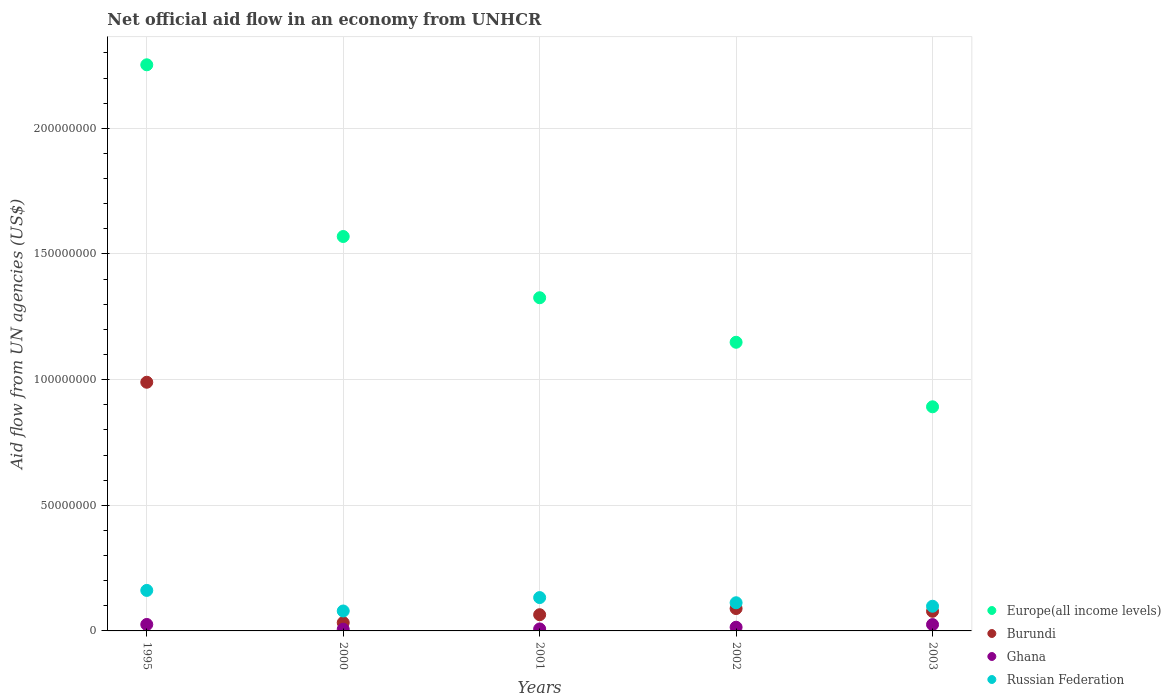How many different coloured dotlines are there?
Offer a terse response. 4. Is the number of dotlines equal to the number of legend labels?
Provide a short and direct response. Yes. What is the net official aid flow in Russian Federation in 2003?
Offer a very short reply. 9.82e+06. Across all years, what is the maximum net official aid flow in Europe(all income levels)?
Ensure brevity in your answer.  2.25e+08. Across all years, what is the minimum net official aid flow in Europe(all income levels)?
Your answer should be compact. 8.92e+07. In which year was the net official aid flow in Ghana maximum?
Keep it short and to the point. 1995. In which year was the net official aid flow in Europe(all income levels) minimum?
Offer a terse response. 2003. What is the total net official aid flow in Burundi in the graph?
Offer a very short reply. 1.25e+08. What is the difference between the net official aid flow in Burundi in 2001 and that in 2003?
Offer a very short reply. -1.36e+06. What is the difference between the net official aid flow in Europe(all income levels) in 2002 and the net official aid flow in Ghana in 2001?
Ensure brevity in your answer.  1.14e+08. What is the average net official aid flow in Europe(all income levels) per year?
Provide a short and direct response. 1.44e+08. In the year 2000, what is the difference between the net official aid flow in Russian Federation and net official aid flow in Ghana?
Your answer should be compact. 7.25e+06. What is the ratio of the net official aid flow in Ghana in 1995 to that in 2001?
Offer a very short reply. 3.25. What is the difference between the highest and the second highest net official aid flow in Ghana?
Provide a succinct answer. 4.00e+04. What is the difference between the highest and the lowest net official aid flow in Europe(all income levels)?
Offer a terse response. 1.36e+08. Is the sum of the net official aid flow in Europe(all income levels) in 2001 and 2003 greater than the maximum net official aid flow in Russian Federation across all years?
Give a very brief answer. Yes. Is it the case that in every year, the sum of the net official aid flow in Burundi and net official aid flow in Ghana  is greater than the net official aid flow in Europe(all income levels)?
Keep it short and to the point. No. Is the net official aid flow in Ghana strictly greater than the net official aid flow in Europe(all income levels) over the years?
Provide a succinct answer. No. How many years are there in the graph?
Your response must be concise. 5. Are the values on the major ticks of Y-axis written in scientific E-notation?
Give a very brief answer. No. Where does the legend appear in the graph?
Make the answer very short. Bottom right. How are the legend labels stacked?
Provide a short and direct response. Vertical. What is the title of the graph?
Give a very brief answer. Net official aid flow in an economy from UNHCR. What is the label or title of the X-axis?
Offer a terse response. Years. What is the label or title of the Y-axis?
Offer a very short reply. Aid flow from UN agencies (US$). What is the Aid flow from UN agencies (US$) in Europe(all income levels) in 1995?
Offer a terse response. 2.25e+08. What is the Aid flow from UN agencies (US$) of Burundi in 1995?
Give a very brief answer. 9.90e+07. What is the Aid flow from UN agencies (US$) in Ghana in 1995?
Give a very brief answer. 2.57e+06. What is the Aid flow from UN agencies (US$) in Russian Federation in 1995?
Offer a terse response. 1.61e+07. What is the Aid flow from UN agencies (US$) of Europe(all income levels) in 2000?
Your response must be concise. 1.57e+08. What is the Aid flow from UN agencies (US$) of Burundi in 2000?
Give a very brief answer. 3.29e+06. What is the Aid flow from UN agencies (US$) of Ghana in 2000?
Provide a short and direct response. 6.80e+05. What is the Aid flow from UN agencies (US$) of Russian Federation in 2000?
Offer a very short reply. 7.93e+06. What is the Aid flow from UN agencies (US$) of Europe(all income levels) in 2001?
Your response must be concise. 1.33e+08. What is the Aid flow from UN agencies (US$) of Burundi in 2001?
Offer a very short reply. 6.45e+06. What is the Aid flow from UN agencies (US$) in Ghana in 2001?
Your answer should be compact. 7.90e+05. What is the Aid flow from UN agencies (US$) of Russian Federation in 2001?
Your answer should be very brief. 1.33e+07. What is the Aid flow from UN agencies (US$) of Europe(all income levels) in 2002?
Your answer should be very brief. 1.15e+08. What is the Aid flow from UN agencies (US$) in Burundi in 2002?
Give a very brief answer. 8.90e+06. What is the Aid flow from UN agencies (US$) of Ghana in 2002?
Offer a very short reply. 1.47e+06. What is the Aid flow from UN agencies (US$) of Russian Federation in 2002?
Give a very brief answer. 1.12e+07. What is the Aid flow from UN agencies (US$) of Europe(all income levels) in 2003?
Give a very brief answer. 8.92e+07. What is the Aid flow from UN agencies (US$) in Burundi in 2003?
Keep it short and to the point. 7.81e+06. What is the Aid flow from UN agencies (US$) in Ghana in 2003?
Make the answer very short. 2.53e+06. What is the Aid flow from UN agencies (US$) in Russian Federation in 2003?
Keep it short and to the point. 9.82e+06. Across all years, what is the maximum Aid flow from UN agencies (US$) of Europe(all income levels)?
Offer a very short reply. 2.25e+08. Across all years, what is the maximum Aid flow from UN agencies (US$) of Burundi?
Your response must be concise. 9.90e+07. Across all years, what is the maximum Aid flow from UN agencies (US$) in Ghana?
Make the answer very short. 2.57e+06. Across all years, what is the maximum Aid flow from UN agencies (US$) in Russian Federation?
Offer a very short reply. 1.61e+07. Across all years, what is the minimum Aid flow from UN agencies (US$) of Europe(all income levels)?
Offer a very short reply. 8.92e+07. Across all years, what is the minimum Aid flow from UN agencies (US$) of Burundi?
Keep it short and to the point. 3.29e+06. Across all years, what is the minimum Aid flow from UN agencies (US$) in Ghana?
Provide a short and direct response. 6.80e+05. Across all years, what is the minimum Aid flow from UN agencies (US$) in Russian Federation?
Provide a succinct answer. 7.93e+06. What is the total Aid flow from UN agencies (US$) in Europe(all income levels) in the graph?
Your answer should be compact. 7.19e+08. What is the total Aid flow from UN agencies (US$) of Burundi in the graph?
Provide a short and direct response. 1.25e+08. What is the total Aid flow from UN agencies (US$) of Ghana in the graph?
Keep it short and to the point. 8.04e+06. What is the total Aid flow from UN agencies (US$) in Russian Federation in the graph?
Ensure brevity in your answer.  5.84e+07. What is the difference between the Aid flow from UN agencies (US$) in Europe(all income levels) in 1995 and that in 2000?
Your answer should be compact. 6.83e+07. What is the difference between the Aid flow from UN agencies (US$) of Burundi in 1995 and that in 2000?
Provide a succinct answer. 9.57e+07. What is the difference between the Aid flow from UN agencies (US$) of Ghana in 1995 and that in 2000?
Your answer should be compact. 1.89e+06. What is the difference between the Aid flow from UN agencies (US$) in Russian Federation in 1995 and that in 2000?
Give a very brief answer. 8.19e+06. What is the difference between the Aid flow from UN agencies (US$) of Europe(all income levels) in 1995 and that in 2001?
Make the answer very short. 9.27e+07. What is the difference between the Aid flow from UN agencies (US$) of Burundi in 1995 and that in 2001?
Make the answer very short. 9.25e+07. What is the difference between the Aid flow from UN agencies (US$) in Ghana in 1995 and that in 2001?
Your response must be concise. 1.78e+06. What is the difference between the Aid flow from UN agencies (US$) of Russian Federation in 1995 and that in 2001?
Your answer should be very brief. 2.85e+06. What is the difference between the Aid flow from UN agencies (US$) of Europe(all income levels) in 1995 and that in 2002?
Your answer should be compact. 1.10e+08. What is the difference between the Aid flow from UN agencies (US$) in Burundi in 1995 and that in 2002?
Your response must be concise. 9.01e+07. What is the difference between the Aid flow from UN agencies (US$) in Ghana in 1995 and that in 2002?
Keep it short and to the point. 1.10e+06. What is the difference between the Aid flow from UN agencies (US$) in Russian Federation in 1995 and that in 2002?
Offer a terse response. 4.91e+06. What is the difference between the Aid flow from UN agencies (US$) of Europe(all income levels) in 1995 and that in 2003?
Offer a very short reply. 1.36e+08. What is the difference between the Aid flow from UN agencies (US$) in Burundi in 1995 and that in 2003?
Your answer should be very brief. 9.12e+07. What is the difference between the Aid flow from UN agencies (US$) of Ghana in 1995 and that in 2003?
Your answer should be very brief. 4.00e+04. What is the difference between the Aid flow from UN agencies (US$) in Russian Federation in 1995 and that in 2003?
Ensure brevity in your answer.  6.30e+06. What is the difference between the Aid flow from UN agencies (US$) in Europe(all income levels) in 2000 and that in 2001?
Your response must be concise. 2.44e+07. What is the difference between the Aid flow from UN agencies (US$) of Burundi in 2000 and that in 2001?
Keep it short and to the point. -3.16e+06. What is the difference between the Aid flow from UN agencies (US$) in Ghana in 2000 and that in 2001?
Offer a very short reply. -1.10e+05. What is the difference between the Aid flow from UN agencies (US$) of Russian Federation in 2000 and that in 2001?
Ensure brevity in your answer.  -5.34e+06. What is the difference between the Aid flow from UN agencies (US$) in Europe(all income levels) in 2000 and that in 2002?
Offer a very short reply. 4.21e+07. What is the difference between the Aid flow from UN agencies (US$) of Burundi in 2000 and that in 2002?
Provide a short and direct response. -5.61e+06. What is the difference between the Aid flow from UN agencies (US$) in Ghana in 2000 and that in 2002?
Ensure brevity in your answer.  -7.90e+05. What is the difference between the Aid flow from UN agencies (US$) in Russian Federation in 2000 and that in 2002?
Ensure brevity in your answer.  -3.28e+06. What is the difference between the Aid flow from UN agencies (US$) of Europe(all income levels) in 2000 and that in 2003?
Your answer should be compact. 6.78e+07. What is the difference between the Aid flow from UN agencies (US$) of Burundi in 2000 and that in 2003?
Your answer should be compact. -4.52e+06. What is the difference between the Aid flow from UN agencies (US$) of Ghana in 2000 and that in 2003?
Provide a succinct answer. -1.85e+06. What is the difference between the Aid flow from UN agencies (US$) in Russian Federation in 2000 and that in 2003?
Offer a terse response. -1.89e+06. What is the difference between the Aid flow from UN agencies (US$) of Europe(all income levels) in 2001 and that in 2002?
Your answer should be very brief. 1.77e+07. What is the difference between the Aid flow from UN agencies (US$) of Burundi in 2001 and that in 2002?
Ensure brevity in your answer.  -2.45e+06. What is the difference between the Aid flow from UN agencies (US$) in Ghana in 2001 and that in 2002?
Ensure brevity in your answer.  -6.80e+05. What is the difference between the Aid flow from UN agencies (US$) of Russian Federation in 2001 and that in 2002?
Your answer should be very brief. 2.06e+06. What is the difference between the Aid flow from UN agencies (US$) of Europe(all income levels) in 2001 and that in 2003?
Ensure brevity in your answer.  4.34e+07. What is the difference between the Aid flow from UN agencies (US$) in Burundi in 2001 and that in 2003?
Provide a succinct answer. -1.36e+06. What is the difference between the Aid flow from UN agencies (US$) of Ghana in 2001 and that in 2003?
Your answer should be compact. -1.74e+06. What is the difference between the Aid flow from UN agencies (US$) of Russian Federation in 2001 and that in 2003?
Your response must be concise. 3.45e+06. What is the difference between the Aid flow from UN agencies (US$) of Europe(all income levels) in 2002 and that in 2003?
Provide a succinct answer. 2.57e+07. What is the difference between the Aid flow from UN agencies (US$) in Burundi in 2002 and that in 2003?
Your answer should be very brief. 1.09e+06. What is the difference between the Aid flow from UN agencies (US$) in Ghana in 2002 and that in 2003?
Your answer should be compact. -1.06e+06. What is the difference between the Aid flow from UN agencies (US$) of Russian Federation in 2002 and that in 2003?
Give a very brief answer. 1.39e+06. What is the difference between the Aid flow from UN agencies (US$) in Europe(all income levels) in 1995 and the Aid flow from UN agencies (US$) in Burundi in 2000?
Offer a terse response. 2.22e+08. What is the difference between the Aid flow from UN agencies (US$) in Europe(all income levels) in 1995 and the Aid flow from UN agencies (US$) in Ghana in 2000?
Keep it short and to the point. 2.25e+08. What is the difference between the Aid flow from UN agencies (US$) of Europe(all income levels) in 1995 and the Aid flow from UN agencies (US$) of Russian Federation in 2000?
Provide a succinct answer. 2.17e+08. What is the difference between the Aid flow from UN agencies (US$) in Burundi in 1995 and the Aid flow from UN agencies (US$) in Ghana in 2000?
Keep it short and to the point. 9.83e+07. What is the difference between the Aid flow from UN agencies (US$) of Burundi in 1995 and the Aid flow from UN agencies (US$) of Russian Federation in 2000?
Your response must be concise. 9.10e+07. What is the difference between the Aid flow from UN agencies (US$) in Ghana in 1995 and the Aid flow from UN agencies (US$) in Russian Federation in 2000?
Provide a succinct answer. -5.36e+06. What is the difference between the Aid flow from UN agencies (US$) in Europe(all income levels) in 1995 and the Aid flow from UN agencies (US$) in Burundi in 2001?
Provide a succinct answer. 2.19e+08. What is the difference between the Aid flow from UN agencies (US$) in Europe(all income levels) in 1995 and the Aid flow from UN agencies (US$) in Ghana in 2001?
Ensure brevity in your answer.  2.24e+08. What is the difference between the Aid flow from UN agencies (US$) of Europe(all income levels) in 1995 and the Aid flow from UN agencies (US$) of Russian Federation in 2001?
Offer a very short reply. 2.12e+08. What is the difference between the Aid flow from UN agencies (US$) of Burundi in 1995 and the Aid flow from UN agencies (US$) of Ghana in 2001?
Make the answer very short. 9.82e+07. What is the difference between the Aid flow from UN agencies (US$) of Burundi in 1995 and the Aid flow from UN agencies (US$) of Russian Federation in 2001?
Your answer should be very brief. 8.57e+07. What is the difference between the Aid flow from UN agencies (US$) in Ghana in 1995 and the Aid flow from UN agencies (US$) in Russian Federation in 2001?
Provide a short and direct response. -1.07e+07. What is the difference between the Aid flow from UN agencies (US$) of Europe(all income levels) in 1995 and the Aid flow from UN agencies (US$) of Burundi in 2002?
Provide a succinct answer. 2.16e+08. What is the difference between the Aid flow from UN agencies (US$) in Europe(all income levels) in 1995 and the Aid flow from UN agencies (US$) in Ghana in 2002?
Provide a succinct answer. 2.24e+08. What is the difference between the Aid flow from UN agencies (US$) of Europe(all income levels) in 1995 and the Aid flow from UN agencies (US$) of Russian Federation in 2002?
Offer a very short reply. 2.14e+08. What is the difference between the Aid flow from UN agencies (US$) in Burundi in 1995 and the Aid flow from UN agencies (US$) in Ghana in 2002?
Provide a succinct answer. 9.75e+07. What is the difference between the Aid flow from UN agencies (US$) of Burundi in 1995 and the Aid flow from UN agencies (US$) of Russian Federation in 2002?
Provide a succinct answer. 8.78e+07. What is the difference between the Aid flow from UN agencies (US$) of Ghana in 1995 and the Aid flow from UN agencies (US$) of Russian Federation in 2002?
Your response must be concise. -8.64e+06. What is the difference between the Aid flow from UN agencies (US$) in Europe(all income levels) in 1995 and the Aid flow from UN agencies (US$) in Burundi in 2003?
Offer a terse response. 2.17e+08. What is the difference between the Aid flow from UN agencies (US$) in Europe(all income levels) in 1995 and the Aid flow from UN agencies (US$) in Ghana in 2003?
Keep it short and to the point. 2.23e+08. What is the difference between the Aid flow from UN agencies (US$) in Europe(all income levels) in 1995 and the Aid flow from UN agencies (US$) in Russian Federation in 2003?
Give a very brief answer. 2.15e+08. What is the difference between the Aid flow from UN agencies (US$) of Burundi in 1995 and the Aid flow from UN agencies (US$) of Ghana in 2003?
Your answer should be compact. 9.64e+07. What is the difference between the Aid flow from UN agencies (US$) of Burundi in 1995 and the Aid flow from UN agencies (US$) of Russian Federation in 2003?
Give a very brief answer. 8.91e+07. What is the difference between the Aid flow from UN agencies (US$) of Ghana in 1995 and the Aid flow from UN agencies (US$) of Russian Federation in 2003?
Offer a terse response. -7.25e+06. What is the difference between the Aid flow from UN agencies (US$) of Europe(all income levels) in 2000 and the Aid flow from UN agencies (US$) of Burundi in 2001?
Give a very brief answer. 1.51e+08. What is the difference between the Aid flow from UN agencies (US$) in Europe(all income levels) in 2000 and the Aid flow from UN agencies (US$) in Ghana in 2001?
Make the answer very short. 1.56e+08. What is the difference between the Aid flow from UN agencies (US$) of Europe(all income levels) in 2000 and the Aid flow from UN agencies (US$) of Russian Federation in 2001?
Ensure brevity in your answer.  1.44e+08. What is the difference between the Aid flow from UN agencies (US$) of Burundi in 2000 and the Aid flow from UN agencies (US$) of Ghana in 2001?
Provide a succinct answer. 2.50e+06. What is the difference between the Aid flow from UN agencies (US$) of Burundi in 2000 and the Aid flow from UN agencies (US$) of Russian Federation in 2001?
Offer a terse response. -9.98e+06. What is the difference between the Aid flow from UN agencies (US$) in Ghana in 2000 and the Aid flow from UN agencies (US$) in Russian Federation in 2001?
Provide a short and direct response. -1.26e+07. What is the difference between the Aid flow from UN agencies (US$) of Europe(all income levels) in 2000 and the Aid flow from UN agencies (US$) of Burundi in 2002?
Provide a succinct answer. 1.48e+08. What is the difference between the Aid flow from UN agencies (US$) in Europe(all income levels) in 2000 and the Aid flow from UN agencies (US$) in Ghana in 2002?
Provide a short and direct response. 1.55e+08. What is the difference between the Aid flow from UN agencies (US$) in Europe(all income levels) in 2000 and the Aid flow from UN agencies (US$) in Russian Federation in 2002?
Your answer should be compact. 1.46e+08. What is the difference between the Aid flow from UN agencies (US$) of Burundi in 2000 and the Aid flow from UN agencies (US$) of Ghana in 2002?
Offer a terse response. 1.82e+06. What is the difference between the Aid flow from UN agencies (US$) in Burundi in 2000 and the Aid flow from UN agencies (US$) in Russian Federation in 2002?
Offer a terse response. -7.92e+06. What is the difference between the Aid flow from UN agencies (US$) of Ghana in 2000 and the Aid flow from UN agencies (US$) of Russian Federation in 2002?
Provide a succinct answer. -1.05e+07. What is the difference between the Aid flow from UN agencies (US$) of Europe(all income levels) in 2000 and the Aid flow from UN agencies (US$) of Burundi in 2003?
Provide a succinct answer. 1.49e+08. What is the difference between the Aid flow from UN agencies (US$) of Europe(all income levels) in 2000 and the Aid flow from UN agencies (US$) of Ghana in 2003?
Your answer should be very brief. 1.54e+08. What is the difference between the Aid flow from UN agencies (US$) of Europe(all income levels) in 2000 and the Aid flow from UN agencies (US$) of Russian Federation in 2003?
Offer a very short reply. 1.47e+08. What is the difference between the Aid flow from UN agencies (US$) in Burundi in 2000 and the Aid flow from UN agencies (US$) in Ghana in 2003?
Your response must be concise. 7.60e+05. What is the difference between the Aid flow from UN agencies (US$) of Burundi in 2000 and the Aid flow from UN agencies (US$) of Russian Federation in 2003?
Give a very brief answer. -6.53e+06. What is the difference between the Aid flow from UN agencies (US$) of Ghana in 2000 and the Aid flow from UN agencies (US$) of Russian Federation in 2003?
Give a very brief answer. -9.14e+06. What is the difference between the Aid flow from UN agencies (US$) in Europe(all income levels) in 2001 and the Aid flow from UN agencies (US$) in Burundi in 2002?
Provide a short and direct response. 1.24e+08. What is the difference between the Aid flow from UN agencies (US$) in Europe(all income levels) in 2001 and the Aid flow from UN agencies (US$) in Ghana in 2002?
Your answer should be compact. 1.31e+08. What is the difference between the Aid flow from UN agencies (US$) of Europe(all income levels) in 2001 and the Aid flow from UN agencies (US$) of Russian Federation in 2002?
Offer a very short reply. 1.21e+08. What is the difference between the Aid flow from UN agencies (US$) in Burundi in 2001 and the Aid flow from UN agencies (US$) in Ghana in 2002?
Provide a succinct answer. 4.98e+06. What is the difference between the Aid flow from UN agencies (US$) in Burundi in 2001 and the Aid flow from UN agencies (US$) in Russian Federation in 2002?
Your response must be concise. -4.76e+06. What is the difference between the Aid flow from UN agencies (US$) of Ghana in 2001 and the Aid flow from UN agencies (US$) of Russian Federation in 2002?
Make the answer very short. -1.04e+07. What is the difference between the Aid flow from UN agencies (US$) in Europe(all income levels) in 2001 and the Aid flow from UN agencies (US$) in Burundi in 2003?
Offer a very short reply. 1.25e+08. What is the difference between the Aid flow from UN agencies (US$) in Europe(all income levels) in 2001 and the Aid flow from UN agencies (US$) in Ghana in 2003?
Provide a short and direct response. 1.30e+08. What is the difference between the Aid flow from UN agencies (US$) in Europe(all income levels) in 2001 and the Aid flow from UN agencies (US$) in Russian Federation in 2003?
Provide a succinct answer. 1.23e+08. What is the difference between the Aid flow from UN agencies (US$) of Burundi in 2001 and the Aid flow from UN agencies (US$) of Ghana in 2003?
Make the answer very short. 3.92e+06. What is the difference between the Aid flow from UN agencies (US$) in Burundi in 2001 and the Aid flow from UN agencies (US$) in Russian Federation in 2003?
Your answer should be compact. -3.37e+06. What is the difference between the Aid flow from UN agencies (US$) in Ghana in 2001 and the Aid flow from UN agencies (US$) in Russian Federation in 2003?
Give a very brief answer. -9.03e+06. What is the difference between the Aid flow from UN agencies (US$) in Europe(all income levels) in 2002 and the Aid flow from UN agencies (US$) in Burundi in 2003?
Make the answer very short. 1.07e+08. What is the difference between the Aid flow from UN agencies (US$) of Europe(all income levels) in 2002 and the Aid flow from UN agencies (US$) of Ghana in 2003?
Offer a terse response. 1.12e+08. What is the difference between the Aid flow from UN agencies (US$) in Europe(all income levels) in 2002 and the Aid flow from UN agencies (US$) in Russian Federation in 2003?
Keep it short and to the point. 1.05e+08. What is the difference between the Aid flow from UN agencies (US$) of Burundi in 2002 and the Aid flow from UN agencies (US$) of Ghana in 2003?
Offer a very short reply. 6.37e+06. What is the difference between the Aid flow from UN agencies (US$) of Burundi in 2002 and the Aid flow from UN agencies (US$) of Russian Federation in 2003?
Offer a terse response. -9.20e+05. What is the difference between the Aid flow from UN agencies (US$) of Ghana in 2002 and the Aid flow from UN agencies (US$) of Russian Federation in 2003?
Your answer should be very brief. -8.35e+06. What is the average Aid flow from UN agencies (US$) in Europe(all income levels) per year?
Keep it short and to the point. 1.44e+08. What is the average Aid flow from UN agencies (US$) in Burundi per year?
Your answer should be very brief. 2.51e+07. What is the average Aid flow from UN agencies (US$) in Ghana per year?
Provide a short and direct response. 1.61e+06. What is the average Aid flow from UN agencies (US$) of Russian Federation per year?
Provide a short and direct response. 1.17e+07. In the year 1995, what is the difference between the Aid flow from UN agencies (US$) of Europe(all income levels) and Aid flow from UN agencies (US$) of Burundi?
Keep it short and to the point. 1.26e+08. In the year 1995, what is the difference between the Aid flow from UN agencies (US$) of Europe(all income levels) and Aid flow from UN agencies (US$) of Ghana?
Offer a terse response. 2.23e+08. In the year 1995, what is the difference between the Aid flow from UN agencies (US$) of Europe(all income levels) and Aid flow from UN agencies (US$) of Russian Federation?
Offer a very short reply. 2.09e+08. In the year 1995, what is the difference between the Aid flow from UN agencies (US$) of Burundi and Aid flow from UN agencies (US$) of Ghana?
Ensure brevity in your answer.  9.64e+07. In the year 1995, what is the difference between the Aid flow from UN agencies (US$) in Burundi and Aid flow from UN agencies (US$) in Russian Federation?
Provide a succinct answer. 8.28e+07. In the year 1995, what is the difference between the Aid flow from UN agencies (US$) of Ghana and Aid flow from UN agencies (US$) of Russian Federation?
Your response must be concise. -1.36e+07. In the year 2000, what is the difference between the Aid flow from UN agencies (US$) in Europe(all income levels) and Aid flow from UN agencies (US$) in Burundi?
Provide a succinct answer. 1.54e+08. In the year 2000, what is the difference between the Aid flow from UN agencies (US$) of Europe(all income levels) and Aid flow from UN agencies (US$) of Ghana?
Your answer should be very brief. 1.56e+08. In the year 2000, what is the difference between the Aid flow from UN agencies (US$) of Europe(all income levels) and Aid flow from UN agencies (US$) of Russian Federation?
Your answer should be compact. 1.49e+08. In the year 2000, what is the difference between the Aid flow from UN agencies (US$) of Burundi and Aid flow from UN agencies (US$) of Ghana?
Offer a terse response. 2.61e+06. In the year 2000, what is the difference between the Aid flow from UN agencies (US$) in Burundi and Aid flow from UN agencies (US$) in Russian Federation?
Your answer should be compact. -4.64e+06. In the year 2000, what is the difference between the Aid flow from UN agencies (US$) in Ghana and Aid flow from UN agencies (US$) in Russian Federation?
Your answer should be very brief. -7.25e+06. In the year 2001, what is the difference between the Aid flow from UN agencies (US$) of Europe(all income levels) and Aid flow from UN agencies (US$) of Burundi?
Give a very brief answer. 1.26e+08. In the year 2001, what is the difference between the Aid flow from UN agencies (US$) of Europe(all income levels) and Aid flow from UN agencies (US$) of Ghana?
Provide a short and direct response. 1.32e+08. In the year 2001, what is the difference between the Aid flow from UN agencies (US$) in Europe(all income levels) and Aid flow from UN agencies (US$) in Russian Federation?
Your answer should be very brief. 1.19e+08. In the year 2001, what is the difference between the Aid flow from UN agencies (US$) of Burundi and Aid flow from UN agencies (US$) of Ghana?
Give a very brief answer. 5.66e+06. In the year 2001, what is the difference between the Aid flow from UN agencies (US$) in Burundi and Aid flow from UN agencies (US$) in Russian Federation?
Ensure brevity in your answer.  -6.82e+06. In the year 2001, what is the difference between the Aid flow from UN agencies (US$) in Ghana and Aid flow from UN agencies (US$) in Russian Federation?
Keep it short and to the point. -1.25e+07. In the year 2002, what is the difference between the Aid flow from UN agencies (US$) of Europe(all income levels) and Aid flow from UN agencies (US$) of Burundi?
Offer a terse response. 1.06e+08. In the year 2002, what is the difference between the Aid flow from UN agencies (US$) of Europe(all income levels) and Aid flow from UN agencies (US$) of Ghana?
Provide a succinct answer. 1.13e+08. In the year 2002, what is the difference between the Aid flow from UN agencies (US$) in Europe(all income levels) and Aid flow from UN agencies (US$) in Russian Federation?
Provide a succinct answer. 1.04e+08. In the year 2002, what is the difference between the Aid flow from UN agencies (US$) of Burundi and Aid flow from UN agencies (US$) of Ghana?
Provide a short and direct response. 7.43e+06. In the year 2002, what is the difference between the Aid flow from UN agencies (US$) of Burundi and Aid flow from UN agencies (US$) of Russian Federation?
Provide a succinct answer. -2.31e+06. In the year 2002, what is the difference between the Aid flow from UN agencies (US$) in Ghana and Aid flow from UN agencies (US$) in Russian Federation?
Make the answer very short. -9.74e+06. In the year 2003, what is the difference between the Aid flow from UN agencies (US$) in Europe(all income levels) and Aid flow from UN agencies (US$) in Burundi?
Offer a terse response. 8.14e+07. In the year 2003, what is the difference between the Aid flow from UN agencies (US$) of Europe(all income levels) and Aid flow from UN agencies (US$) of Ghana?
Your response must be concise. 8.67e+07. In the year 2003, what is the difference between the Aid flow from UN agencies (US$) of Europe(all income levels) and Aid flow from UN agencies (US$) of Russian Federation?
Give a very brief answer. 7.94e+07. In the year 2003, what is the difference between the Aid flow from UN agencies (US$) of Burundi and Aid flow from UN agencies (US$) of Ghana?
Make the answer very short. 5.28e+06. In the year 2003, what is the difference between the Aid flow from UN agencies (US$) in Burundi and Aid flow from UN agencies (US$) in Russian Federation?
Provide a short and direct response. -2.01e+06. In the year 2003, what is the difference between the Aid flow from UN agencies (US$) in Ghana and Aid flow from UN agencies (US$) in Russian Federation?
Ensure brevity in your answer.  -7.29e+06. What is the ratio of the Aid flow from UN agencies (US$) in Europe(all income levels) in 1995 to that in 2000?
Ensure brevity in your answer.  1.44. What is the ratio of the Aid flow from UN agencies (US$) in Burundi in 1995 to that in 2000?
Give a very brief answer. 30.08. What is the ratio of the Aid flow from UN agencies (US$) of Ghana in 1995 to that in 2000?
Keep it short and to the point. 3.78. What is the ratio of the Aid flow from UN agencies (US$) in Russian Federation in 1995 to that in 2000?
Your answer should be very brief. 2.03. What is the ratio of the Aid flow from UN agencies (US$) of Europe(all income levels) in 1995 to that in 2001?
Offer a very short reply. 1.7. What is the ratio of the Aid flow from UN agencies (US$) in Burundi in 1995 to that in 2001?
Give a very brief answer. 15.34. What is the ratio of the Aid flow from UN agencies (US$) in Ghana in 1995 to that in 2001?
Provide a short and direct response. 3.25. What is the ratio of the Aid flow from UN agencies (US$) of Russian Federation in 1995 to that in 2001?
Give a very brief answer. 1.21. What is the ratio of the Aid flow from UN agencies (US$) of Europe(all income levels) in 1995 to that in 2002?
Your answer should be compact. 1.96. What is the ratio of the Aid flow from UN agencies (US$) of Burundi in 1995 to that in 2002?
Offer a very short reply. 11.12. What is the ratio of the Aid flow from UN agencies (US$) in Ghana in 1995 to that in 2002?
Offer a very short reply. 1.75. What is the ratio of the Aid flow from UN agencies (US$) in Russian Federation in 1995 to that in 2002?
Ensure brevity in your answer.  1.44. What is the ratio of the Aid flow from UN agencies (US$) of Europe(all income levels) in 1995 to that in 2003?
Give a very brief answer. 2.53. What is the ratio of the Aid flow from UN agencies (US$) of Burundi in 1995 to that in 2003?
Give a very brief answer. 12.67. What is the ratio of the Aid flow from UN agencies (US$) in Ghana in 1995 to that in 2003?
Give a very brief answer. 1.02. What is the ratio of the Aid flow from UN agencies (US$) in Russian Federation in 1995 to that in 2003?
Make the answer very short. 1.64. What is the ratio of the Aid flow from UN agencies (US$) in Europe(all income levels) in 2000 to that in 2001?
Provide a short and direct response. 1.18. What is the ratio of the Aid flow from UN agencies (US$) of Burundi in 2000 to that in 2001?
Provide a short and direct response. 0.51. What is the ratio of the Aid flow from UN agencies (US$) of Ghana in 2000 to that in 2001?
Your answer should be very brief. 0.86. What is the ratio of the Aid flow from UN agencies (US$) in Russian Federation in 2000 to that in 2001?
Ensure brevity in your answer.  0.6. What is the ratio of the Aid flow from UN agencies (US$) in Europe(all income levels) in 2000 to that in 2002?
Ensure brevity in your answer.  1.37. What is the ratio of the Aid flow from UN agencies (US$) in Burundi in 2000 to that in 2002?
Give a very brief answer. 0.37. What is the ratio of the Aid flow from UN agencies (US$) of Ghana in 2000 to that in 2002?
Keep it short and to the point. 0.46. What is the ratio of the Aid flow from UN agencies (US$) in Russian Federation in 2000 to that in 2002?
Ensure brevity in your answer.  0.71. What is the ratio of the Aid flow from UN agencies (US$) of Europe(all income levels) in 2000 to that in 2003?
Keep it short and to the point. 1.76. What is the ratio of the Aid flow from UN agencies (US$) of Burundi in 2000 to that in 2003?
Provide a succinct answer. 0.42. What is the ratio of the Aid flow from UN agencies (US$) of Ghana in 2000 to that in 2003?
Your answer should be compact. 0.27. What is the ratio of the Aid flow from UN agencies (US$) of Russian Federation in 2000 to that in 2003?
Ensure brevity in your answer.  0.81. What is the ratio of the Aid flow from UN agencies (US$) of Europe(all income levels) in 2001 to that in 2002?
Your response must be concise. 1.15. What is the ratio of the Aid flow from UN agencies (US$) in Burundi in 2001 to that in 2002?
Make the answer very short. 0.72. What is the ratio of the Aid flow from UN agencies (US$) in Ghana in 2001 to that in 2002?
Keep it short and to the point. 0.54. What is the ratio of the Aid flow from UN agencies (US$) of Russian Federation in 2001 to that in 2002?
Provide a succinct answer. 1.18. What is the ratio of the Aid flow from UN agencies (US$) in Europe(all income levels) in 2001 to that in 2003?
Provide a short and direct response. 1.49. What is the ratio of the Aid flow from UN agencies (US$) of Burundi in 2001 to that in 2003?
Provide a short and direct response. 0.83. What is the ratio of the Aid flow from UN agencies (US$) in Ghana in 2001 to that in 2003?
Offer a terse response. 0.31. What is the ratio of the Aid flow from UN agencies (US$) in Russian Federation in 2001 to that in 2003?
Provide a succinct answer. 1.35. What is the ratio of the Aid flow from UN agencies (US$) in Europe(all income levels) in 2002 to that in 2003?
Your response must be concise. 1.29. What is the ratio of the Aid flow from UN agencies (US$) in Burundi in 2002 to that in 2003?
Provide a succinct answer. 1.14. What is the ratio of the Aid flow from UN agencies (US$) of Ghana in 2002 to that in 2003?
Your answer should be very brief. 0.58. What is the ratio of the Aid flow from UN agencies (US$) of Russian Federation in 2002 to that in 2003?
Give a very brief answer. 1.14. What is the difference between the highest and the second highest Aid flow from UN agencies (US$) in Europe(all income levels)?
Offer a very short reply. 6.83e+07. What is the difference between the highest and the second highest Aid flow from UN agencies (US$) in Burundi?
Provide a short and direct response. 9.01e+07. What is the difference between the highest and the second highest Aid flow from UN agencies (US$) in Russian Federation?
Make the answer very short. 2.85e+06. What is the difference between the highest and the lowest Aid flow from UN agencies (US$) in Europe(all income levels)?
Offer a very short reply. 1.36e+08. What is the difference between the highest and the lowest Aid flow from UN agencies (US$) of Burundi?
Keep it short and to the point. 9.57e+07. What is the difference between the highest and the lowest Aid flow from UN agencies (US$) of Ghana?
Make the answer very short. 1.89e+06. What is the difference between the highest and the lowest Aid flow from UN agencies (US$) in Russian Federation?
Offer a terse response. 8.19e+06. 